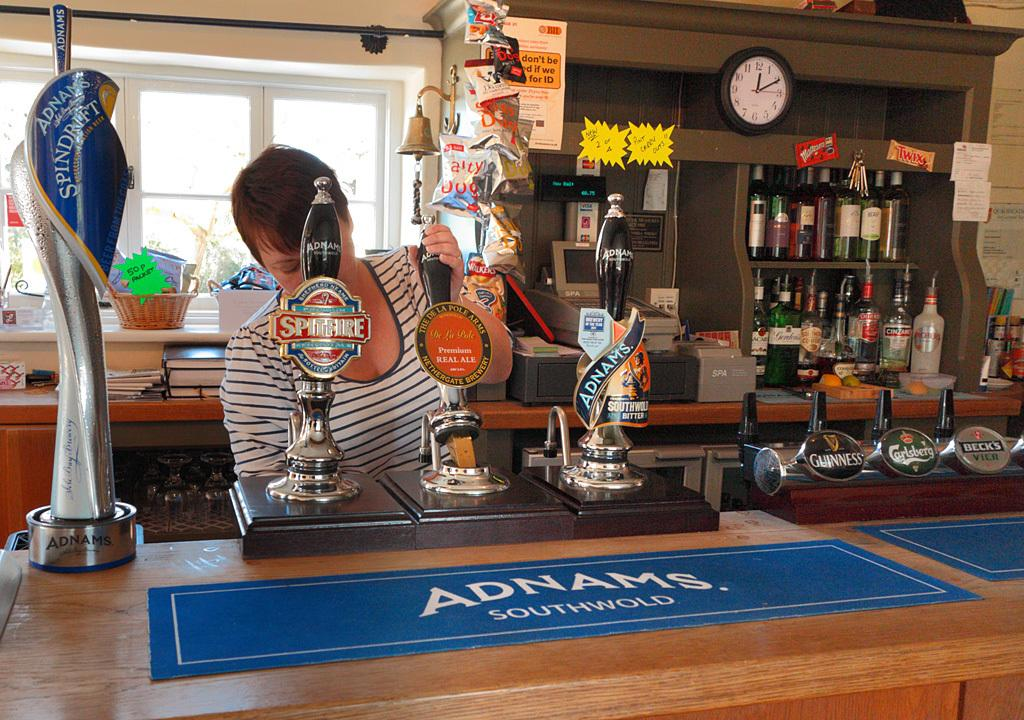<image>
Give a short and clear explanation of the subsequent image. A woman is behind a bar, which features a Adnams Southwold barmat. 